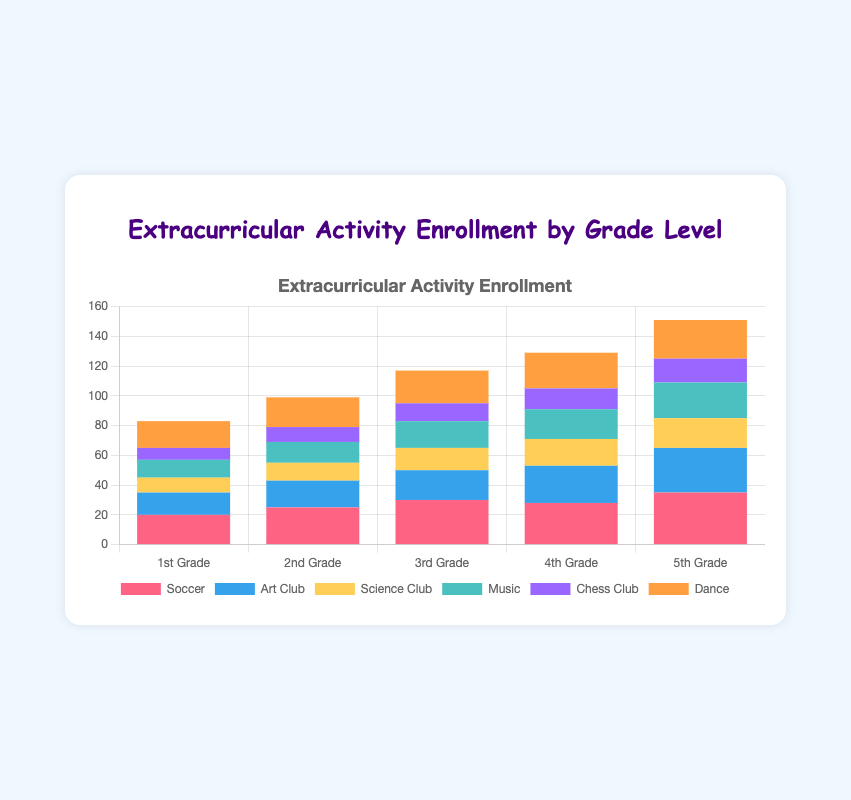Which grade level has the highest enrollment in Soccer? Look at the bar heights for Soccer across all grade levels. The tallest bar is for 5th Grade, indicating it has the highest enrollment in Soccer.
Answer: 5th Grade How many students in total are enrolled in the Science Club across all grade levels? Sum the number of students enrolled in the Science Club for each grade: 10 (1st) + 12 (2nd) + 15 (3rd) + 18 (4th) + 20 (5th). The total is 75.
Answer: 75 Which activity has the lowest enrollment in 3rd Grade? Compare the heights of the bars for 3rd Grade; the shortest bar is for Chess Club.
Answer: Chess Club How much higher is the Music enrollment in 5th Grade compared to 1st Grade? Subtract the Music enrollment in 1st Grade from the Music enrollment in 5th Grade: 24 (5th) - 12 (1st). The difference is 12.
Answer: 12 Which activity shows a consistent increase in enrollment from 1st Grade to 5th Grade? Visually inspect the bar heights for each activity across grades. Dance is the activity with consistently increasing bar heights from 1st Grade to 5th Grade.
Answer: Dance What is the total enrollment for all activities in 4th Grade? Sum the number of students enrolled in each activity for 4th Grade: 28 (Soccer) + 25 (Art Club) + 18 (Science Club) + 20 (Music) + 14 (Chess Club) + 24 (Dance). The total is 129.
Answer: 129 Is the number of students in Dance in 2nd Grade greater than in Art Club in 1st Grade? Compare the Dance enrollment for 2nd Grade (20) with the Art Club enrollment for 1st Grade (15). 20 is greater than 15.
Answer: Yes What is the average enrollment in Chess Club across all grade levels? Sum the number of students enrolled in Chess Club for each grade: 8 (1st) + 10 (2nd) + 12 (3rd) + 14 (4th) + 16 (5th), which is 60. Divide this sum by 5 (the number of grades): 60 / 5 = 12.
Answer: 12 How does the enrollment in the Art Club in 5th Grade compare to the Soccer enrollment in 2nd Grade? Compare the Art Club enrollment for 5th Grade (30) with the Soccer enrollment for 2nd Grade (25). 30 is greater than 25.
Answer: Art Club in 5th Grade is higher Which activity has the same number of enrollees in 2nd Grade and 4th Grade? Compare the bar heights for each activity in 2nd and 4th Grade. Science Club has 12 enrollees in 2nd Grade and 18 in 4th Grade, so no activity has the same number.
Answer: None 